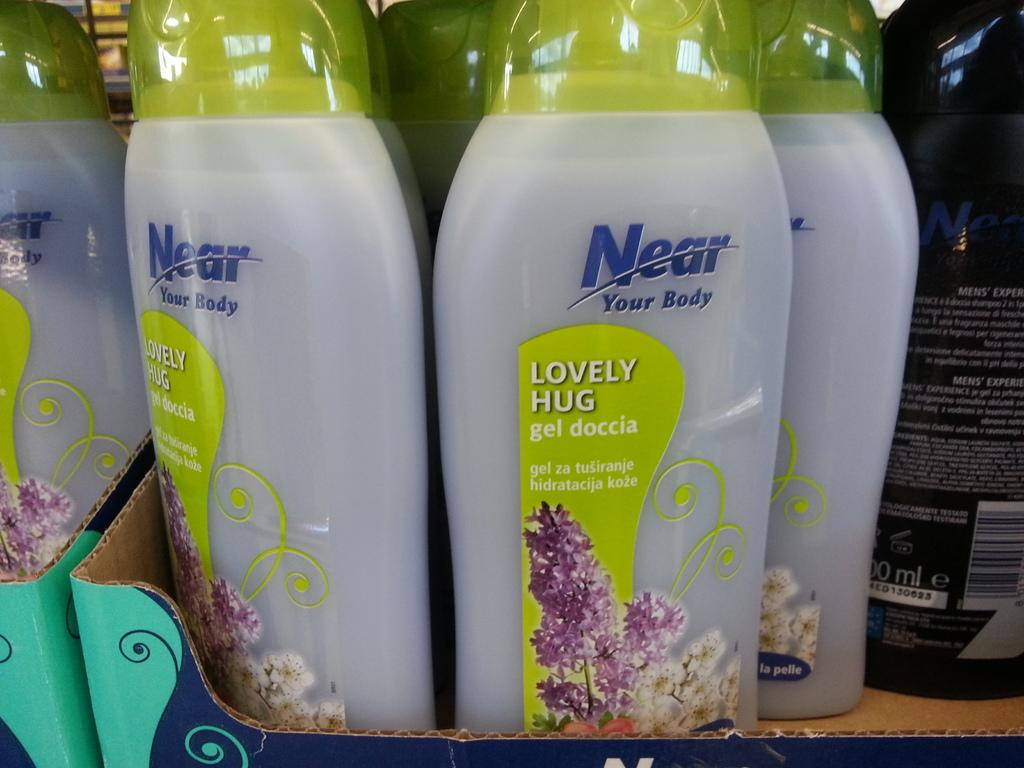<image>
Offer a succinct explanation of the picture presented. Bottles of Near Your Body Lovely Hug gel doccia on a shelf 